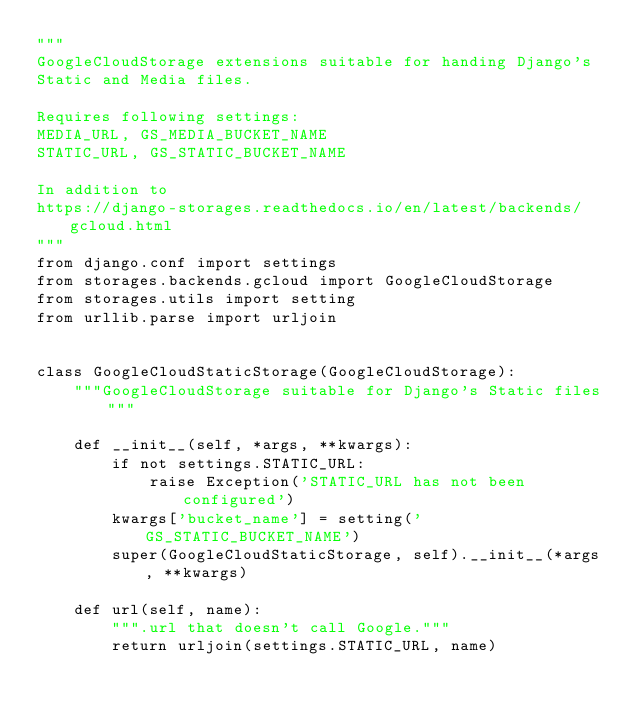Convert code to text. <code><loc_0><loc_0><loc_500><loc_500><_Python_>"""
GoogleCloudStorage extensions suitable for handing Django's
Static and Media files.

Requires following settings:
MEDIA_URL, GS_MEDIA_BUCKET_NAME
STATIC_URL, GS_STATIC_BUCKET_NAME

In addition to
https://django-storages.readthedocs.io/en/latest/backends/gcloud.html
"""
from django.conf import settings
from storages.backends.gcloud import GoogleCloudStorage
from storages.utils import setting
from urllib.parse import urljoin


class GoogleCloudStaticStorage(GoogleCloudStorage):
    """GoogleCloudStorage suitable for Django's Static files"""

    def __init__(self, *args, **kwargs):
        if not settings.STATIC_URL:
            raise Exception('STATIC_URL has not been configured')
        kwargs['bucket_name'] = setting('GS_STATIC_BUCKET_NAME')
        super(GoogleCloudStaticStorage, self).__init__(*args, **kwargs)

    def url(self, name):
        """.url that doesn't call Google."""
        return urljoin(settings.STATIC_URL, name)

</code> 